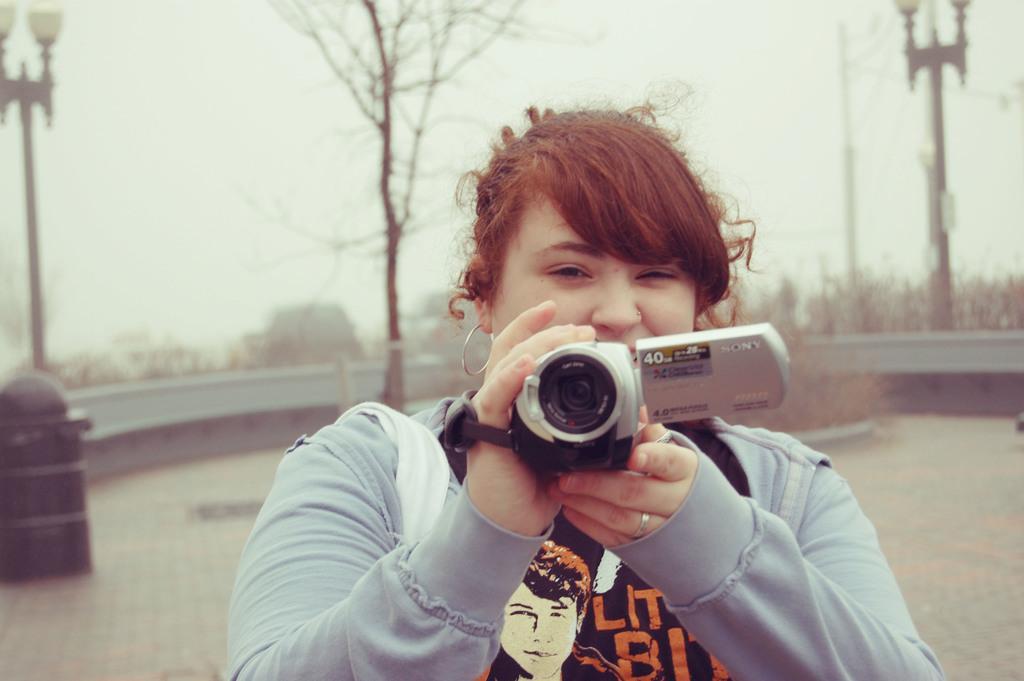Please provide a concise description of this image. In this picture a women in blue jacket holding a camera to the right hand she is having a ring. Background of this women is a wall, tree and sky and there is also a pole with street lights. 